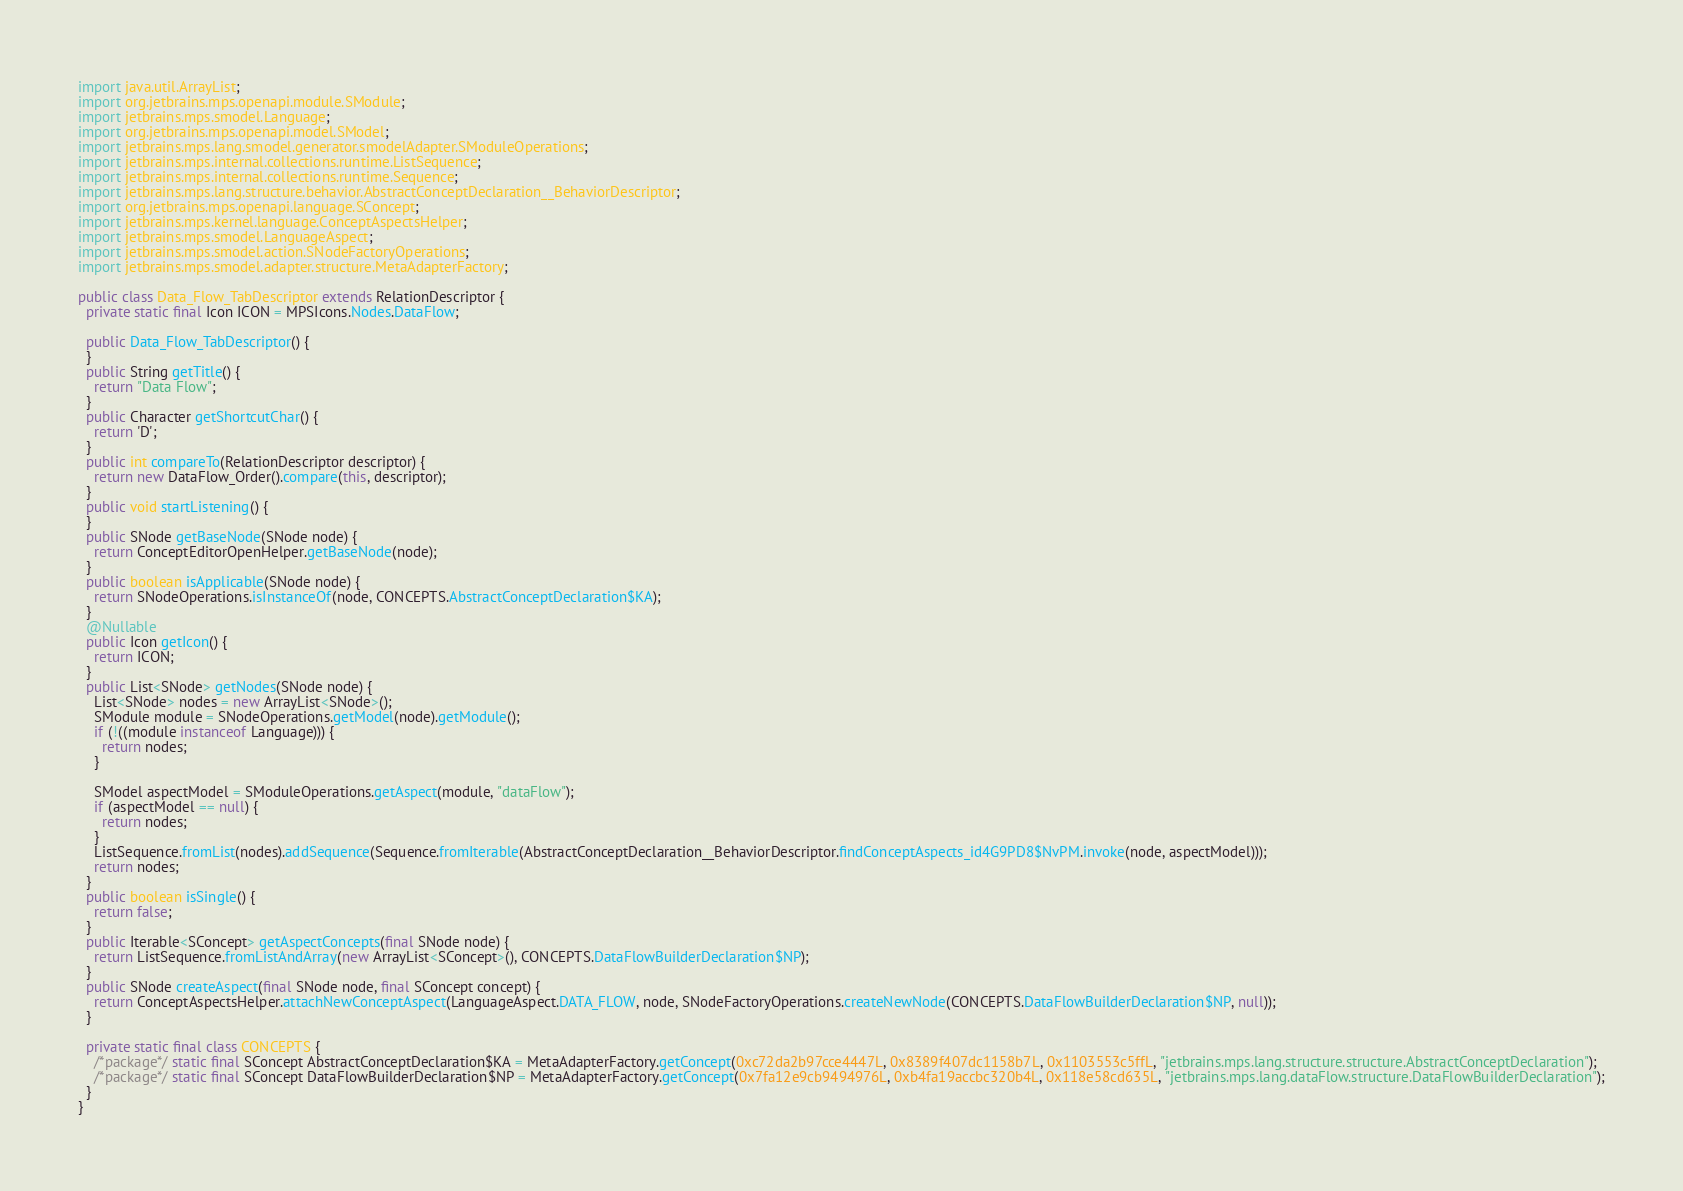Convert code to text. <code><loc_0><loc_0><loc_500><loc_500><_Java_>import java.util.ArrayList;
import org.jetbrains.mps.openapi.module.SModule;
import jetbrains.mps.smodel.Language;
import org.jetbrains.mps.openapi.model.SModel;
import jetbrains.mps.lang.smodel.generator.smodelAdapter.SModuleOperations;
import jetbrains.mps.internal.collections.runtime.ListSequence;
import jetbrains.mps.internal.collections.runtime.Sequence;
import jetbrains.mps.lang.structure.behavior.AbstractConceptDeclaration__BehaviorDescriptor;
import org.jetbrains.mps.openapi.language.SConcept;
import jetbrains.mps.kernel.language.ConceptAspectsHelper;
import jetbrains.mps.smodel.LanguageAspect;
import jetbrains.mps.smodel.action.SNodeFactoryOperations;
import jetbrains.mps.smodel.adapter.structure.MetaAdapterFactory;

public class Data_Flow_TabDescriptor extends RelationDescriptor {
  private static final Icon ICON = MPSIcons.Nodes.DataFlow;

  public Data_Flow_TabDescriptor() {
  }
  public String getTitle() {
    return "Data Flow";
  }
  public Character getShortcutChar() {
    return 'D';
  }
  public int compareTo(RelationDescriptor descriptor) {
    return new DataFlow_Order().compare(this, descriptor);
  }
  public void startListening() {
  }
  public SNode getBaseNode(SNode node) {
    return ConceptEditorOpenHelper.getBaseNode(node);
  }
  public boolean isApplicable(SNode node) {
    return SNodeOperations.isInstanceOf(node, CONCEPTS.AbstractConceptDeclaration$KA);
  }
  @Nullable
  public Icon getIcon() {
    return ICON;
  }
  public List<SNode> getNodes(SNode node) {
    List<SNode> nodes = new ArrayList<SNode>();
    SModule module = SNodeOperations.getModel(node).getModule();
    if (!((module instanceof Language))) {
      return nodes;
    }

    SModel aspectModel = SModuleOperations.getAspect(module, "dataFlow");
    if (aspectModel == null) {
      return nodes;
    }
    ListSequence.fromList(nodes).addSequence(Sequence.fromIterable(AbstractConceptDeclaration__BehaviorDescriptor.findConceptAspects_id4G9PD8$NvPM.invoke(node, aspectModel)));
    return nodes;
  }
  public boolean isSingle() {
    return false;
  }
  public Iterable<SConcept> getAspectConcepts(final SNode node) {
    return ListSequence.fromListAndArray(new ArrayList<SConcept>(), CONCEPTS.DataFlowBuilderDeclaration$NP);
  }
  public SNode createAspect(final SNode node, final SConcept concept) {
    return ConceptAspectsHelper.attachNewConceptAspect(LanguageAspect.DATA_FLOW, node, SNodeFactoryOperations.createNewNode(CONCEPTS.DataFlowBuilderDeclaration$NP, null));
  }

  private static final class CONCEPTS {
    /*package*/ static final SConcept AbstractConceptDeclaration$KA = MetaAdapterFactory.getConcept(0xc72da2b97cce4447L, 0x8389f407dc1158b7L, 0x1103553c5ffL, "jetbrains.mps.lang.structure.structure.AbstractConceptDeclaration");
    /*package*/ static final SConcept DataFlowBuilderDeclaration$NP = MetaAdapterFactory.getConcept(0x7fa12e9cb9494976L, 0xb4fa19accbc320b4L, 0x118e58cd635L, "jetbrains.mps.lang.dataFlow.structure.DataFlowBuilderDeclaration");
  }
}
</code> 